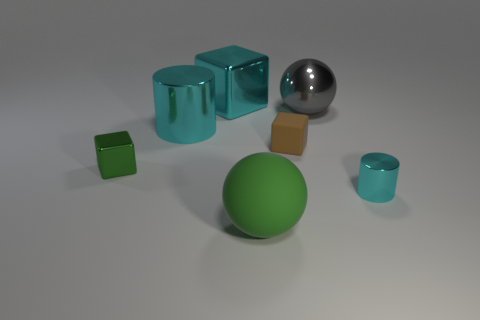Subtract all brown matte blocks. How many blocks are left? 2 Add 2 big blue metallic things. How many objects exist? 9 Subtract all green cubes. How many cubes are left? 2 Subtract 3 blocks. How many blocks are left? 0 Subtract all cubes. How many objects are left? 4 Add 6 small shiny cylinders. How many small shiny cylinders are left? 7 Add 7 large blue shiny cylinders. How many large blue shiny cylinders exist? 7 Subtract 0 yellow cubes. How many objects are left? 7 Subtract all gray balls. Subtract all gray cylinders. How many balls are left? 1 Subtract all yellow balls. How many green cubes are left? 1 